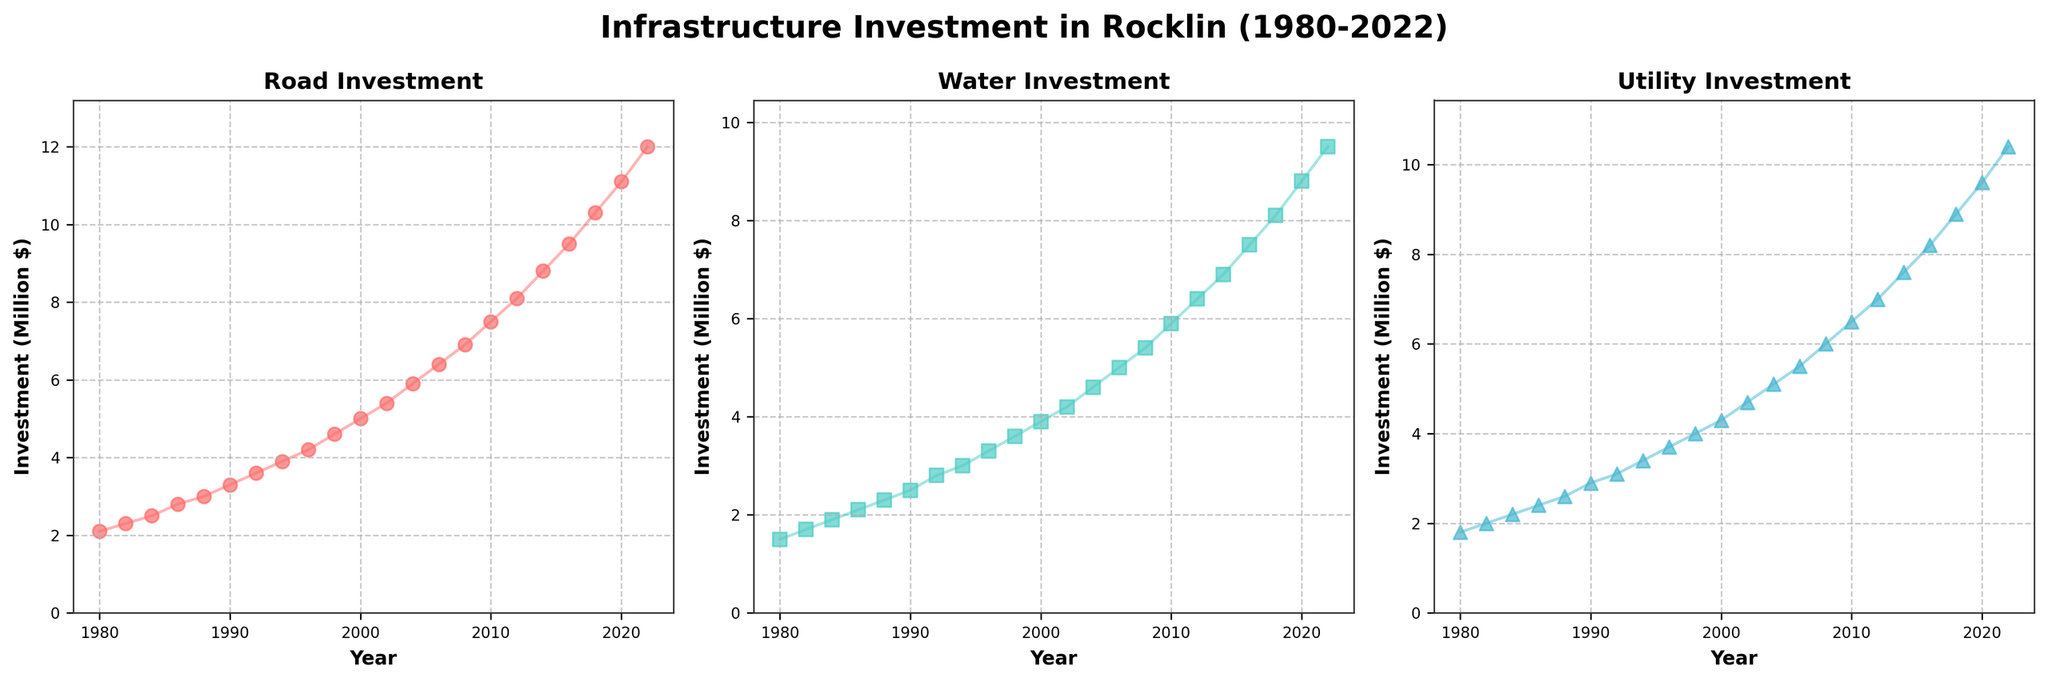Which type of infrastructure investment showed the highest increase over the period? Road investment steadily increased from 2.1 million in 1980 to 12.0 million in 2022, while water and utility investments increased at a slower rate comparatively.
Answer: Road investment What was the difference in investment between road and utility projects in 2022? In 2022, road investment was 12.0 million, and utility investment was 10.4 million. The difference is 12.0 - 10.4 = 1.6 million.
Answer: 1.6 million Which type of investment had the most consistent growth over the years? Looking at the scatter plots, road investments show the most consistent and steady increase without significant fluctuations, unlike water and utility investments which have slight variations in their growth patterns.
Answer: Road investment At what year did water investment exceed 5 million? By observing the water investment subplot, we can see that water investment exceeded 5 million in 2006 when it reached 5.0 million.
Answer: 2006 Between 1990 and 2000, how much did utility investment increase? Utility investment in 1990 was 2.9 million, and in 2000 it increased to 4.3 million. The difference is 4.3 - 2.9 = 1.4 million.
Answer: 1.4 million Which investment category had the smallest value in 1988, and what was it? In 1988, water investment had the smallest value at 2.3 million compared to road (3.0 million) and utility (2.6 million) investments.
Answer: Water investment, 2.3 million How much did road investment increase from 1980 to 2020? Road investment increased from 2.1 million in 1980 to 11.1 million in 2020. The increase is 11.1 - 2.1 = 9.0 million.
Answer: 9.0 million In which year were all three investment types closest in value? In 1980, road, water, and utility investments were relatively close in value at 2.1 million, 1.5 million, and 1.8 million respectively.
Answer: 1980 What is the average investment value for utility projects between 1980 and 2022? Sum the utility investments from 1980 (1.8) to 2022 (10.4) and divide by the number of years (22). Sum is 94.7 million, so the average is 94.7 / 22 = 4.3 million.
Answer: 4.3 million Which type of investment showed the largest increase between any two consecutive time points? The largest increase between two consecutive years occurred in road investment between 2020 and 2022, where it increased from 11.1 million to 12.0 million, a difference of 0.9 million.
Answer: Road investment 